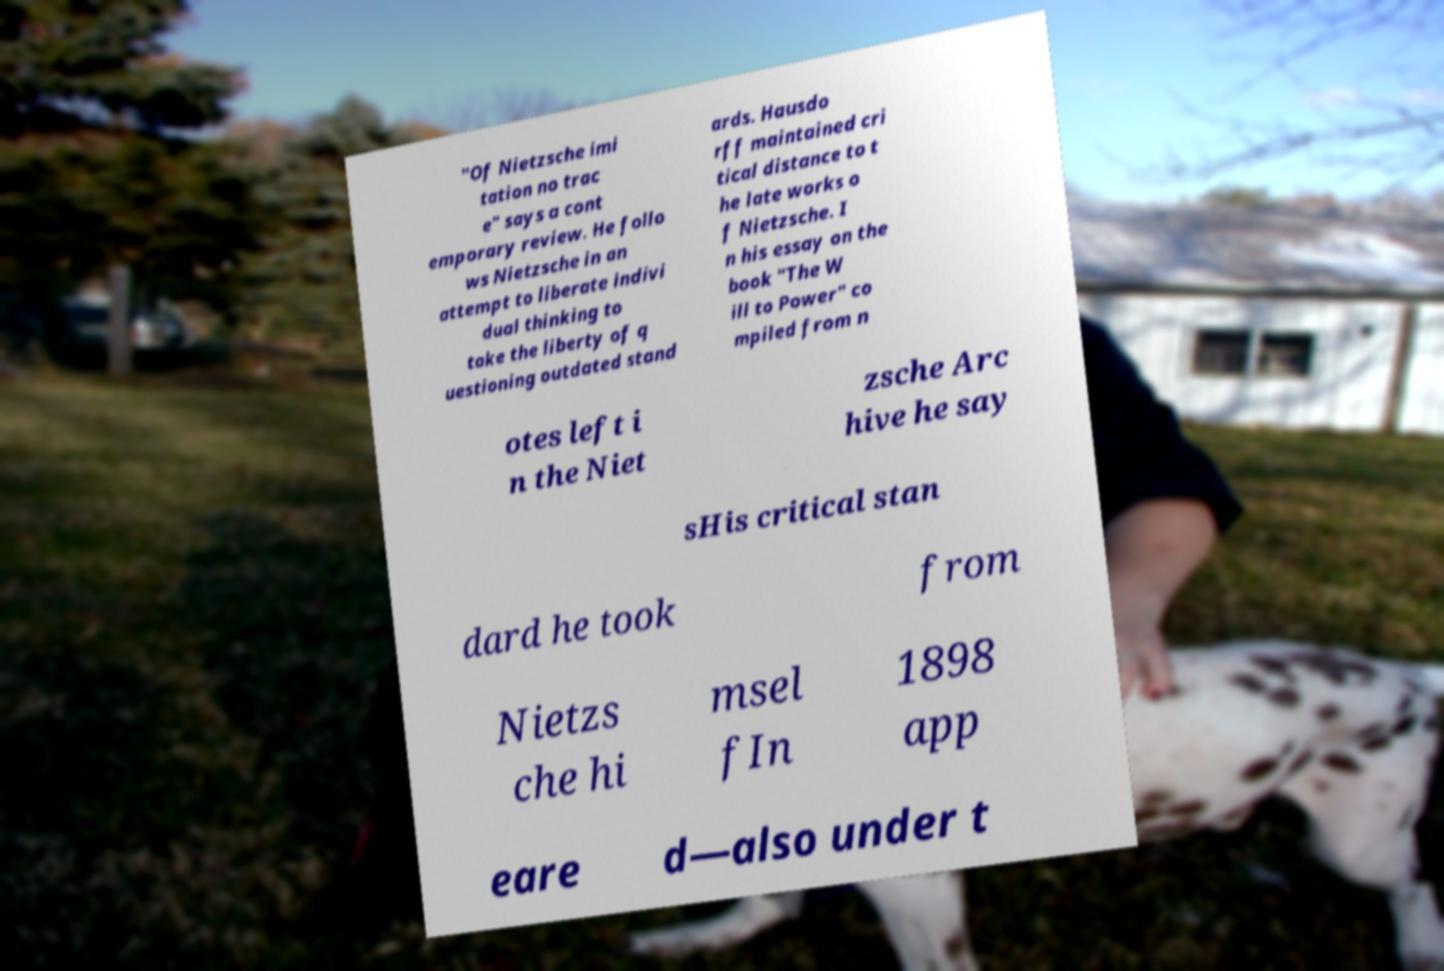I need the written content from this picture converted into text. Can you do that? "Of Nietzsche imi tation no trac e" says a cont emporary review. He follo ws Nietzsche in an attempt to liberate indivi dual thinking to take the liberty of q uestioning outdated stand ards. Hausdo rff maintained cri tical distance to t he late works o f Nietzsche. I n his essay on the book "The W ill to Power" co mpiled from n otes left i n the Niet zsche Arc hive he say sHis critical stan dard he took from Nietzs che hi msel fIn 1898 app eare d—also under t 